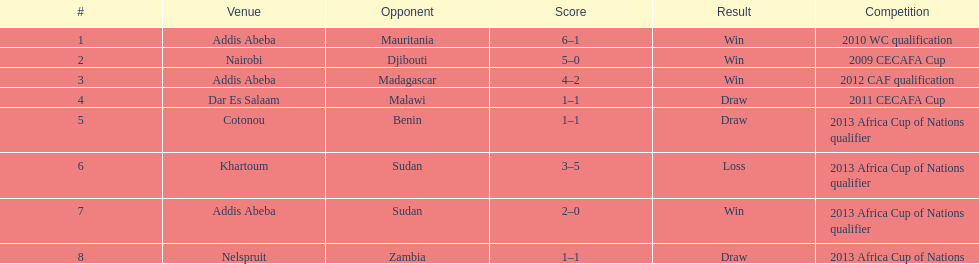Number of different teams listed on the chart 7. 